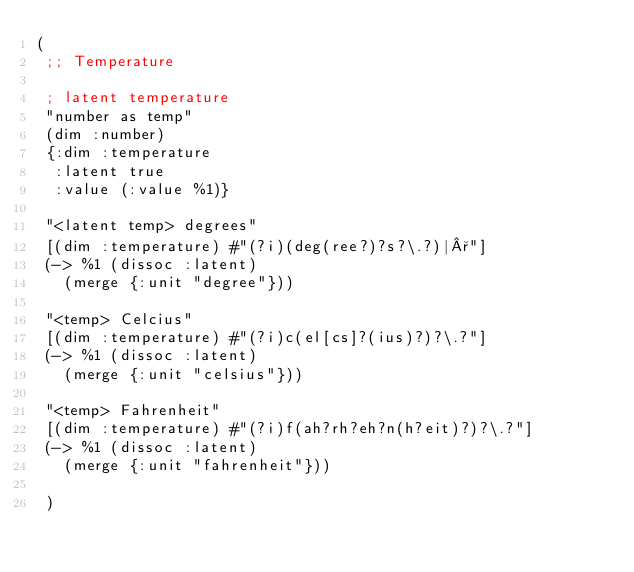<code> <loc_0><loc_0><loc_500><loc_500><_Clojure_>(
 ;; Temperature

 ; latent temperature
 "number as temp"
 (dim :number)
 {:dim :temperature
  :latent true
  :value (:value %1)}

 "<latent temp> degrees"
 [(dim :temperature) #"(?i)(deg(ree?)?s?\.?)|°"]
 (-> %1 (dissoc :latent)
   (merge {:unit "degree"}))

 "<temp> Celcius"
 [(dim :temperature) #"(?i)c(el[cs]?(ius)?)?\.?"]
 (-> %1 (dissoc :latent)
   (merge {:unit "celsius"}))

 "<temp> Fahrenheit"
 [(dim :temperature) #"(?i)f(ah?rh?eh?n(h?eit)?)?\.?"]
 (-> %1 (dissoc :latent)
   (merge {:unit "fahrenheit"}))

 )</code> 